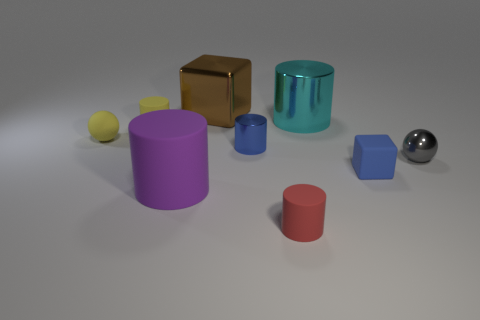Is there anything else that has the same shape as the small red rubber object?
Keep it short and to the point. Yes. The blue object that is the same material as the tiny red cylinder is what shape?
Your answer should be compact. Cube. Are there the same number of tiny gray metal spheres behind the large cyan metallic thing and large brown objects?
Make the answer very short. No. Does the block that is behind the large cyan cylinder have the same material as the small cylinder that is in front of the small blue metallic thing?
Offer a terse response. No. There is a small gray object that is in front of the rubber cylinder behind the small metallic ball; what is its shape?
Your answer should be compact. Sphere. There is a tiny sphere that is made of the same material as the small block; what color is it?
Offer a very short reply. Yellow. Is the rubber ball the same color as the metallic ball?
Keep it short and to the point. No. What shape is the cyan shiny object that is the same size as the shiny block?
Provide a short and direct response. Cylinder. What is the size of the blue rubber cube?
Offer a very short reply. Small. Is the size of the brown metal object behind the tiny red matte cylinder the same as the blue thing that is in front of the small gray object?
Give a very brief answer. No. 